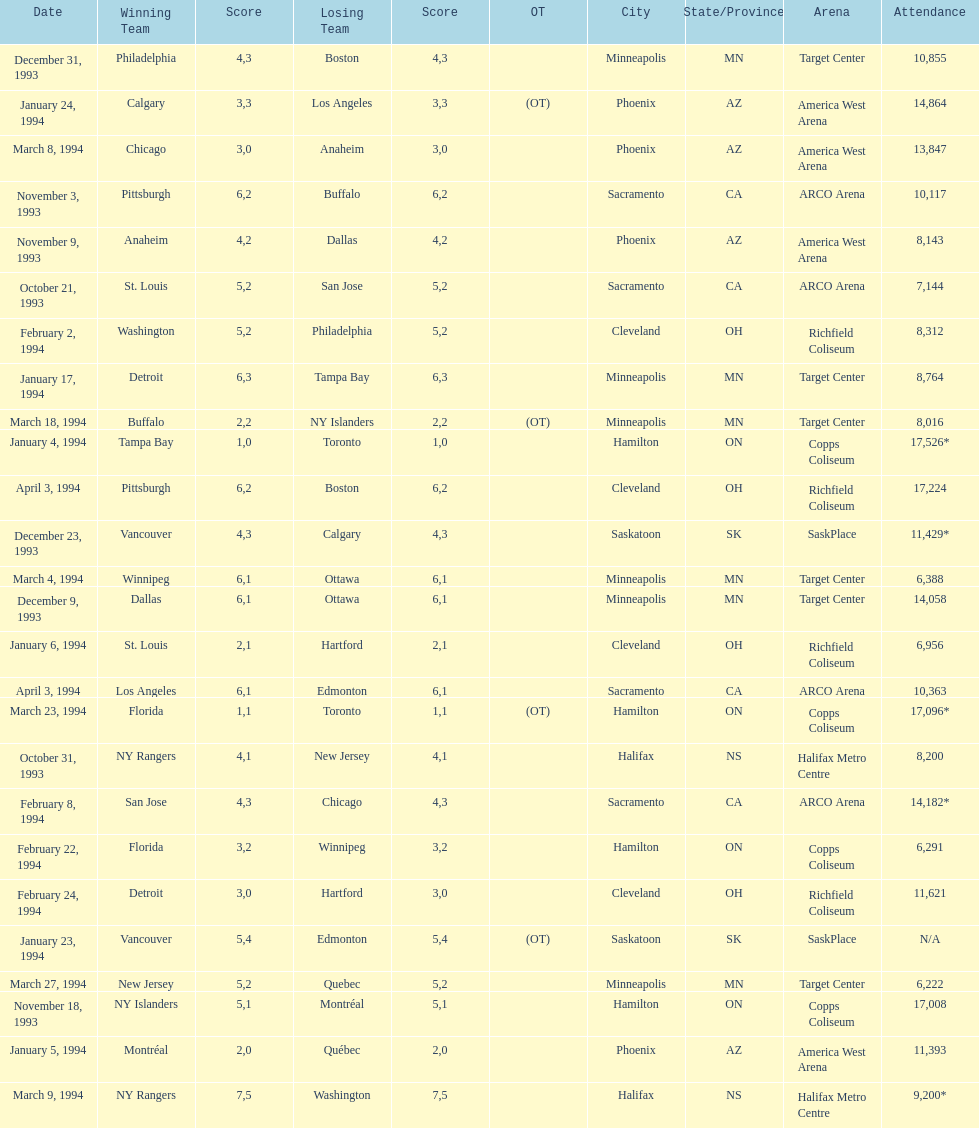How many events occurred in minneapolis, mn? 6. 